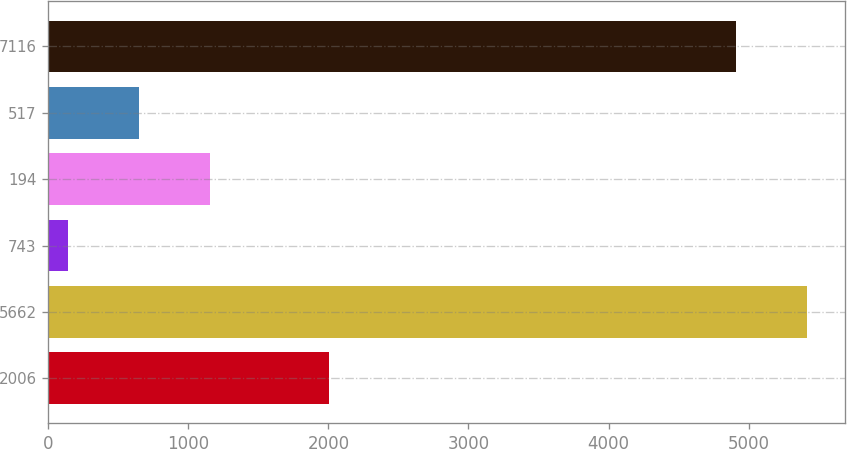<chart> <loc_0><loc_0><loc_500><loc_500><bar_chart><fcel>2006<fcel>5662<fcel>743<fcel>194<fcel>517<fcel>7116<nl><fcel>2005<fcel>5417.3<fcel>140<fcel>1154.6<fcel>647.3<fcel>4910<nl></chart> 